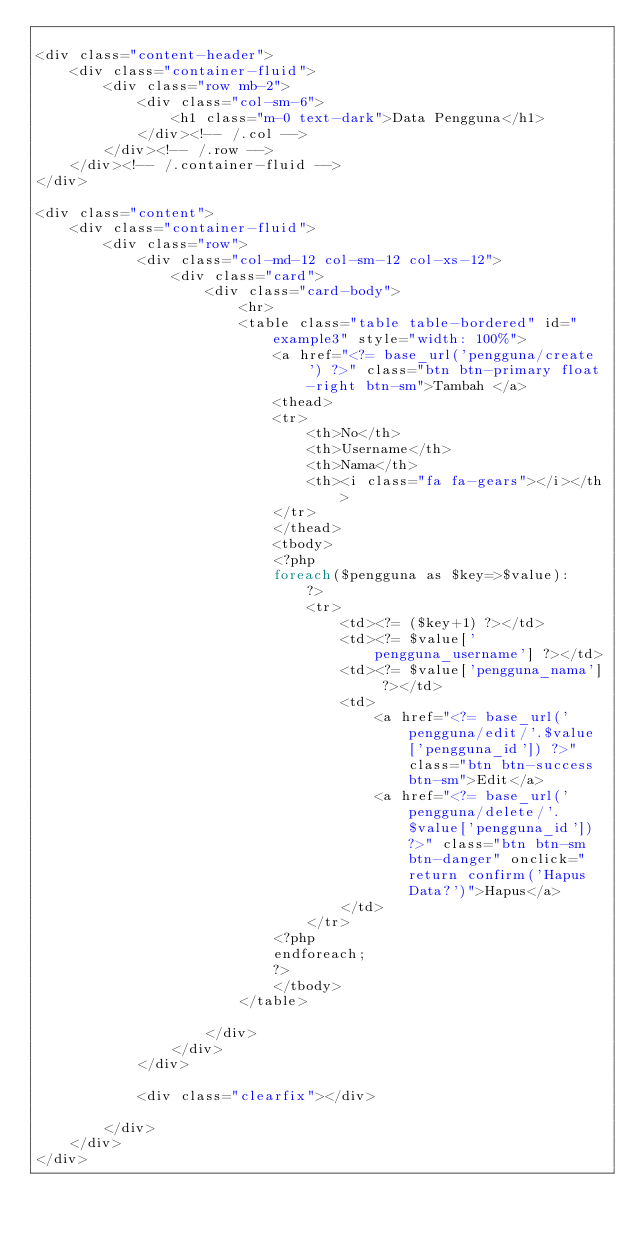<code> <loc_0><loc_0><loc_500><loc_500><_PHP_>
<div class="content-header">
	<div class="container-fluid">
		<div class="row mb-2">
			<div class="col-sm-6">
				<h1 class="m-0 text-dark">Data Pengguna</h1>
			</div><!-- /.col -->
		</div><!-- /.row -->
	</div><!-- /.container-fluid -->
</div>

<div class="content">
	<div class="container-fluid">
		<div class="row">
			<div class="col-md-12 col-sm-12 col-xs-12">
				<div class="card">
					<div class="card-body">
						<hr>
						<table class="table table-bordered" id="example3" style="width: 100%">
							<a href="<?= base_url('pengguna/create') ?>" class="btn btn-primary float-right btn-sm">Tambah </a>
							<thead>
							<tr>
								<th>No</th>
								<th>Username</th>
								<th>Nama</th>
								<th><i class="fa fa-gears"></i></th>
							</tr>
							</thead>
							<tbody>
							<?php
							foreach($pengguna as $key=>$value):
								?>
								<tr>
									<td><?= ($key+1) ?></td>
									<td><?= $value['pengguna_username'] ?></td>
									<td><?= $value['pengguna_nama'] ?></td>
									<td>
										<a href="<?= base_url('pengguna/edit/'.$value['pengguna_id']) ?>" class="btn btn-success btn-sm">Edit</a>
										<a href="<?= base_url('pengguna/delete/'.$value['pengguna_id']) ?>" class="btn btn-sm btn-danger" onclick="return confirm('Hapus Data?')">Hapus</a>
									</td>
								</tr>
							<?php
							endforeach;
							?>
							</tbody>
						</table>

					</div>
				</div>
			</div>

			<div class="clearfix"></div>

		</div>
	</div>
</div>
</code> 